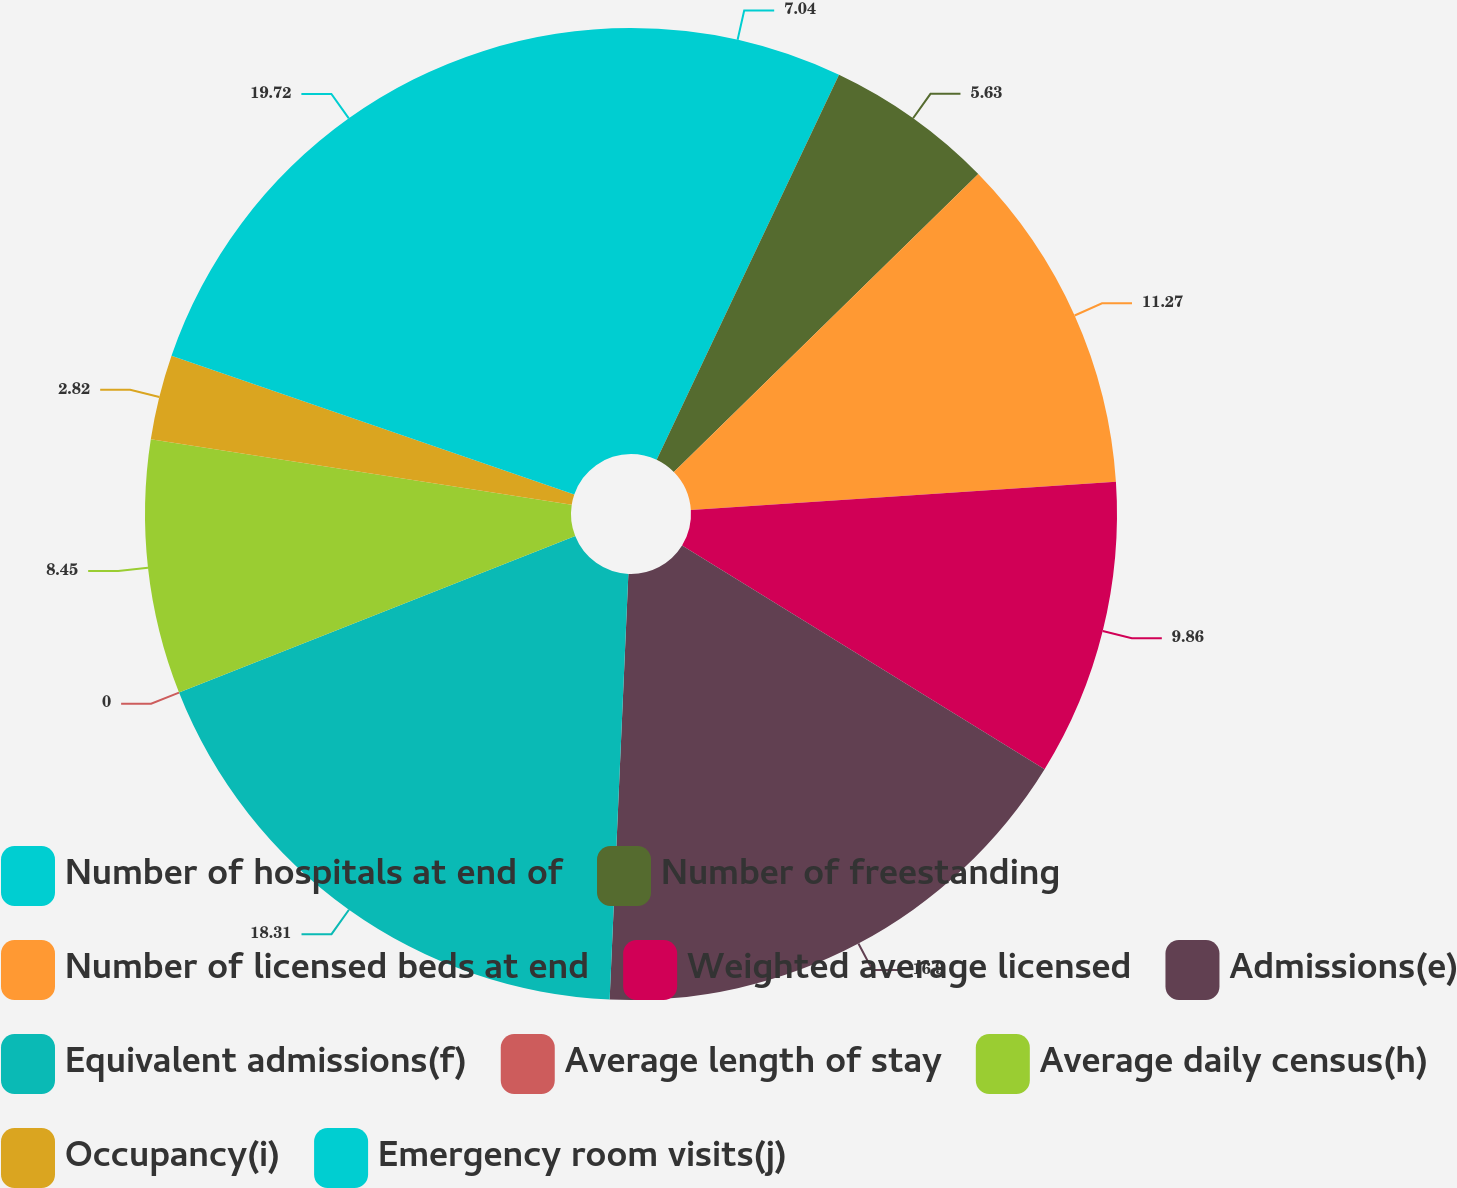Convert chart to OTSL. <chart><loc_0><loc_0><loc_500><loc_500><pie_chart><fcel>Number of hospitals at end of<fcel>Number of freestanding<fcel>Number of licensed beds at end<fcel>Weighted average licensed<fcel>Admissions(e)<fcel>Equivalent admissions(f)<fcel>Average length of stay<fcel>Average daily census(h)<fcel>Occupancy(i)<fcel>Emergency room visits(j)<nl><fcel>7.04%<fcel>5.63%<fcel>11.27%<fcel>9.86%<fcel>16.9%<fcel>18.31%<fcel>0.0%<fcel>8.45%<fcel>2.82%<fcel>19.72%<nl></chart> 